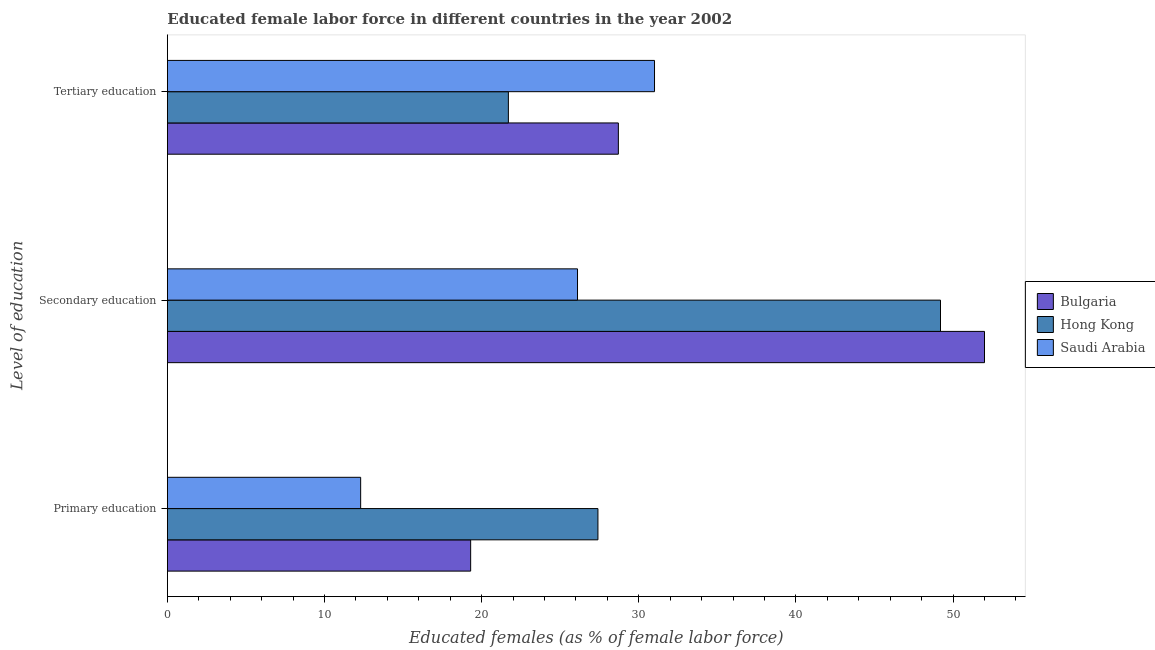Are the number of bars on each tick of the Y-axis equal?
Your response must be concise. Yes. How many bars are there on the 1st tick from the top?
Offer a very short reply. 3. How many bars are there on the 1st tick from the bottom?
Provide a succinct answer. 3. What is the label of the 1st group of bars from the top?
Offer a very short reply. Tertiary education. What is the percentage of female labor force who received tertiary education in Bulgaria?
Provide a short and direct response. 28.7. Across all countries, what is the maximum percentage of female labor force who received tertiary education?
Ensure brevity in your answer.  31. Across all countries, what is the minimum percentage of female labor force who received tertiary education?
Give a very brief answer. 21.7. In which country was the percentage of female labor force who received secondary education maximum?
Offer a terse response. Bulgaria. In which country was the percentage of female labor force who received tertiary education minimum?
Provide a short and direct response. Hong Kong. What is the total percentage of female labor force who received secondary education in the graph?
Offer a very short reply. 127.3. What is the difference between the percentage of female labor force who received primary education in Saudi Arabia and that in Hong Kong?
Provide a succinct answer. -15.1. What is the difference between the percentage of female labor force who received primary education in Bulgaria and the percentage of female labor force who received secondary education in Hong Kong?
Offer a very short reply. -29.9. What is the average percentage of female labor force who received secondary education per country?
Ensure brevity in your answer.  42.43. What is the difference between the percentage of female labor force who received secondary education and percentage of female labor force who received primary education in Hong Kong?
Provide a short and direct response. 21.8. What is the ratio of the percentage of female labor force who received secondary education in Saudi Arabia to that in Hong Kong?
Give a very brief answer. 0.53. Is the percentage of female labor force who received tertiary education in Hong Kong less than that in Saudi Arabia?
Offer a terse response. Yes. Is the difference between the percentage of female labor force who received primary education in Saudi Arabia and Hong Kong greater than the difference between the percentage of female labor force who received secondary education in Saudi Arabia and Hong Kong?
Provide a succinct answer. Yes. What is the difference between the highest and the second highest percentage of female labor force who received tertiary education?
Your answer should be compact. 2.3. What is the difference between the highest and the lowest percentage of female labor force who received tertiary education?
Ensure brevity in your answer.  9.3. What does the 2nd bar from the top in Tertiary education represents?
Provide a succinct answer. Hong Kong. How many countries are there in the graph?
Ensure brevity in your answer.  3. What is the difference between two consecutive major ticks on the X-axis?
Give a very brief answer. 10. Are the values on the major ticks of X-axis written in scientific E-notation?
Keep it short and to the point. No. Where does the legend appear in the graph?
Ensure brevity in your answer.  Center right. What is the title of the graph?
Give a very brief answer. Educated female labor force in different countries in the year 2002. What is the label or title of the X-axis?
Ensure brevity in your answer.  Educated females (as % of female labor force). What is the label or title of the Y-axis?
Offer a terse response. Level of education. What is the Educated females (as % of female labor force) of Bulgaria in Primary education?
Provide a short and direct response. 19.3. What is the Educated females (as % of female labor force) of Hong Kong in Primary education?
Give a very brief answer. 27.4. What is the Educated females (as % of female labor force) in Saudi Arabia in Primary education?
Offer a terse response. 12.3. What is the Educated females (as % of female labor force) of Hong Kong in Secondary education?
Your answer should be very brief. 49.2. What is the Educated females (as % of female labor force) in Saudi Arabia in Secondary education?
Keep it short and to the point. 26.1. What is the Educated females (as % of female labor force) in Bulgaria in Tertiary education?
Give a very brief answer. 28.7. What is the Educated females (as % of female labor force) in Hong Kong in Tertiary education?
Your answer should be very brief. 21.7. Across all Level of education, what is the maximum Educated females (as % of female labor force) of Hong Kong?
Your response must be concise. 49.2. Across all Level of education, what is the minimum Educated females (as % of female labor force) of Bulgaria?
Make the answer very short. 19.3. Across all Level of education, what is the minimum Educated females (as % of female labor force) of Hong Kong?
Your response must be concise. 21.7. Across all Level of education, what is the minimum Educated females (as % of female labor force) in Saudi Arabia?
Your response must be concise. 12.3. What is the total Educated females (as % of female labor force) in Hong Kong in the graph?
Make the answer very short. 98.3. What is the total Educated females (as % of female labor force) of Saudi Arabia in the graph?
Ensure brevity in your answer.  69.4. What is the difference between the Educated females (as % of female labor force) in Bulgaria in Primary education and that in Secondary education?
Keep it short and to the point. -32.7. What is the difference between the Educated females (as % of female labor force) in Hong Kong in Primary education and that in Secondary education?
Ensure brevity in your answer.  -21.8. What is the difference between the Educated females (as % of female labor force) of Saudi Arabia in Primary education and that in Secondary education?
Give a very brief answer. -13.8. What is the difference between the Educated females (as % of female labor force) of Bulgaria in Primary education and that in Tertiary education?
Your answer should be compact. -9.4. What is the difference between the Educated females (as % of female labor force) in Hong Kong in Primary education and that in Tertiary education?
Make the answer very short. 5.7. What is the difference between the Educated females (as % of female labor force) of Saudi Arabia in Primary education and that in Tertiary education?
Provide a succinct answer. -18.7. What is the difference between the Educated females (as % of female labor force) of Bulgaria in Secondary education and that in Tertiary education?
Your answer should be compact. 23.3. What is the difference between the Educated females (as % of female labor force) of Saudi Arabia in Secondary education and that in Tertiary education?
Provide a short and direct response. -4.9. What is the difference between the Educated females (as % of female labor force) of Bulgaria in Primary education and the Educated females (as % of female labor force) of Hong Kong in Secondary education?
Make the answer very short. -29.9. What is the difference between the Educated females (as % of female labor force) in Bulgaria in Primary education and the Educated females (as % of female labor force) in Hong Kong in Tertiary education?
Your answer should be compact. -2.4. What is the difference between the Educated females (as % of female labor force) in Bulgaria in Primary education and the Educated females (as % of female labor force) in Saudi Arabia in Tertiary education?
Your answer should be compact. -11.7. What is the difference between the Educated females (as % of female labor force) in Hong Kong in Primary education and the Educated females (as % of female labor force) in Saudi Arabia in Tertiary education?
Keep it short and to the point. -3.6. What is the difference between the Educated females (as % of female labor force) in Bulgaria in Secondary education and the Educated females (as % of female labor force) in Hong Kong in Tertiary education?
Provide a short and direct response. 30.3. What is the difference between the Educated females (as % of female labor force) in Bulgaria in Secondary education and the Educated females (as % of female labor force) in Saudi Arabia in Tertiary education?
Your answer should be compact. 21. What is the average Educated females (as % of female labor force) of Bulgaria per Level of education?
Keep it short and to the point. 33.33. What is the average Educated females (as % of female labor force) of Hong Kong per Level of education?
Keep it short and to the point. 32.77. What is the average Educated females (as % of female labor force) of Saudi Arabia per Level of education?
Give a very brief answer. 23.13. What is the difference between the Educated females (as % of female labor force) in Hong Kong and Educated females (as % of female labor force) in Saudi Arabia in Primary education?
Provide a succinct answer. 15.1. What is the difference between the Educated females (as % of female labor force) in Bulgaria and Educated females (as % of female labor force) in Saudi Arabia in Secondary education?
Make the answer very short. 25.9. What is the difference between the Educated females (as % of female labor force) of Hong Kong and Educated females (as % of female labor force) of Saudi Arabia in Secondary education?
Your answer should be very brief. 23.1. What is the difference between the Educated females (as % of female labor force) of Bulgaria and Educated females (as % of female labor force) of Hong Kong in Tertiary education?
Your response must be concise. 7. What is the ratio of the Educated females (as % of female labor force) of Bulgaria in Primary education to that in Secondary education?
Offer a very short reply. 0.37. What is the ratio of the Educated females (as % of female labor force) in Hong Kong in Primary education to that in Secondary education?
Offer a very short reply. 0.56. What is the ratio of the Educated females (as % of female labor force) of Saudi Arabia in Primary education to that in Secondary education?
Provide a succinct answer. 0.47. What is the ratio of the Educated females (as % of female labor force) of Bulgaria in Primary education to that in Tertiary education?
Your answer should be compact. 0.67. What is the ratio of the Educated females (as % of female labor force) of Hong Kong in Primary education to that in Tertiary education?
Your answer should be very brief. 1.26. What is the ratio of the Educated females (as % of female labor force) of Saudi Arabia in Primary education to that in Tertiary education?
Your answer should be compact. 0.4. What is the ratio of the Educated females (as % of female labor force) in Bulgaria in Secondary education to that in Tertiary education?
Make the answer very short. 1.81. What is the ratio of the Educated females (as % of female labor force) of Hong Kong in Secondary education to that in Tertiary education?
Offer a very short reply. 2.27. What is the ratio of the Educated females (as % of female labor force) of Saudi Arabia in Secondary education to that in Tertiary education?
Keep it short and to the point. 0.84. What is the difference between the highest and the second highest Educated females (as % of female labor force) of Bulgaria?
Keep it short and to the point. 23.3. What is the difference between the highest and the second highest Educated females (as % of female labor force) in Hong Kong?
Offer a very short reply. 21.8. What is the difference between the highest and the lowest Educated females (as % of female labor force) in Bulgaria?
Offer a terse response. 32.7. 